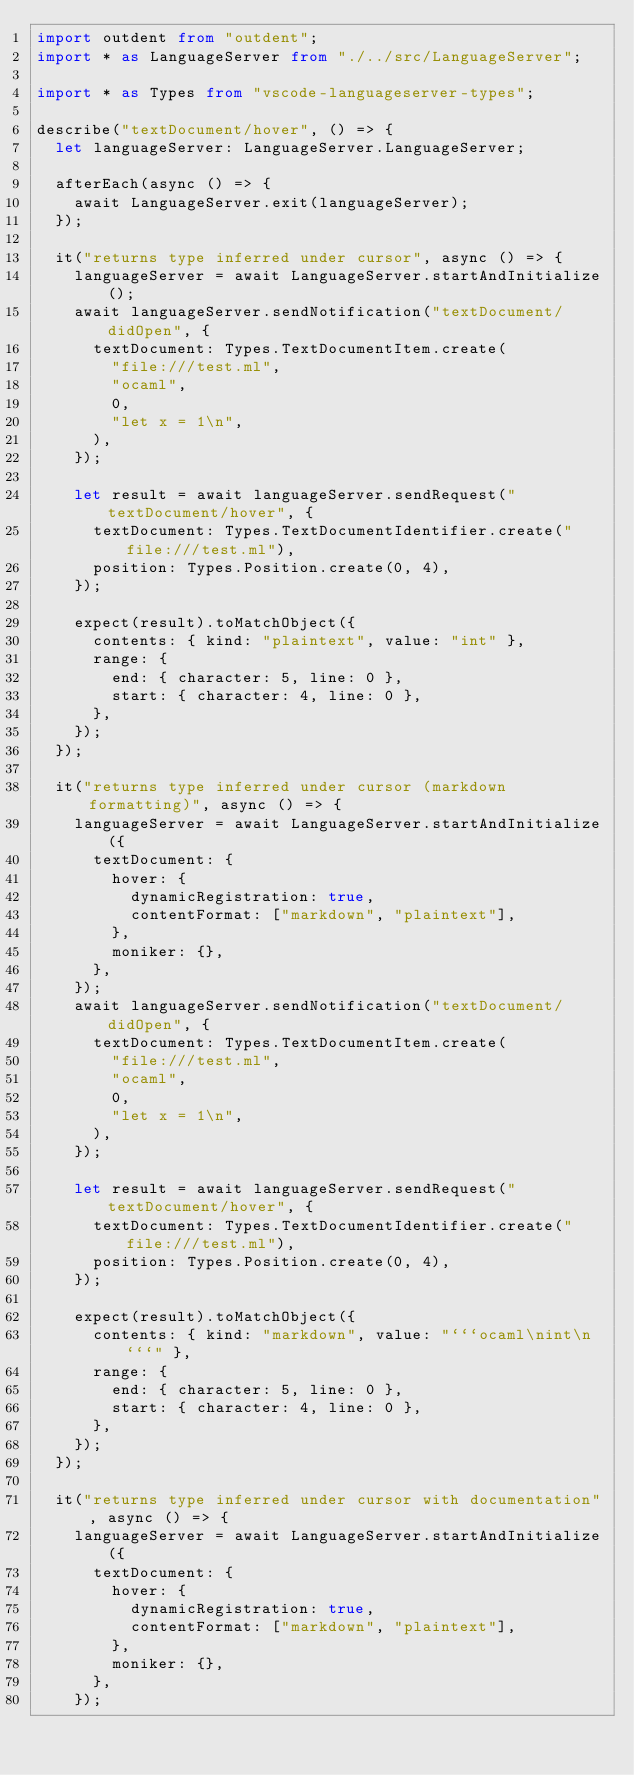Convert code to text. <code><loc_0><loc_0><loc_500><loc_500><_TypeScript_>import outdent from "outdent";
import * as LanguageServer from "./../src/LanguageServer";

import * as Types from "vscode-languageserver-types";

describe("textDocument/hover", () => {
  let languageServer: LanguageServer.LanguageServer;

  afterEach(async () => {
    await LanguageServer.exit(languageServer);
  });

  it("returns type inferred under cursor", async () => {
    languageServer = await LanguageServer.startAndInitialize();
    await languageServer.sendNotification("textDocument/didOpen", {
      textDocument: Types.TextDocumentItem.create(
        "file:///test.ml",
        "ocaml",
        0,
        "let x = 1\n",
      ),
    });

    let result = await languageServer.sendRequest("textDocument/hover", {
      textDocument: Types.TextDocumentIdentifier.create("file:///test.ml"),
      position: Types.Position.create(0, 4),
    });

    expect(result).toMatchObject({
      contents: { kind: "plaintext", value: "int" },
      range: {
        end: { character: 5, line: 0 },
        start: { character: 4, line: 0 },
      },
    });
  });

  it("returns type inferred under cursor (markdown formatting)", async () => {
    languageServer = await LanguageServer.startAndInitialize({
      textDocument: {
        hover: {
          dynamicRegistration: true,
          contentFormat: ["markdown", "plaintext"],
        },
        moniker: {},
      },
    });
    await languageServer.sendNotification("textDocument/didOpen", {
      textDocument: Types.TextDocumentItem.create(
        "file:///test.ml",
        "ocaml",
        0,
        "let x = 1\n",
      ),
    });

    let result = await languageServer.sendRequest("textDocument/hover", {
      textDocument: Types.TextDocumentIdentifier.create("file:///test.ml"),
      position: Types.Position.create(0, 4),
    });

    expect(result).toMatchObject({
      contents: { kind: "markdown", value: "```ocaml\nint\n```" },
      range: {
        end: { character: 5, line: 0 },
        start: { character: 4, line: 0 },
      },
    });
  });

  it("returns type inferred under cursor with documentation", async () => {
    languageServer = await LanguageServer.startAndInitialize({
      textDocument: {
        hover: {
          dynamicRegistration: true,
          contentFormat: ["markdown", "plaintext"],
        },
        moniker: {},
      },
    });</code> 